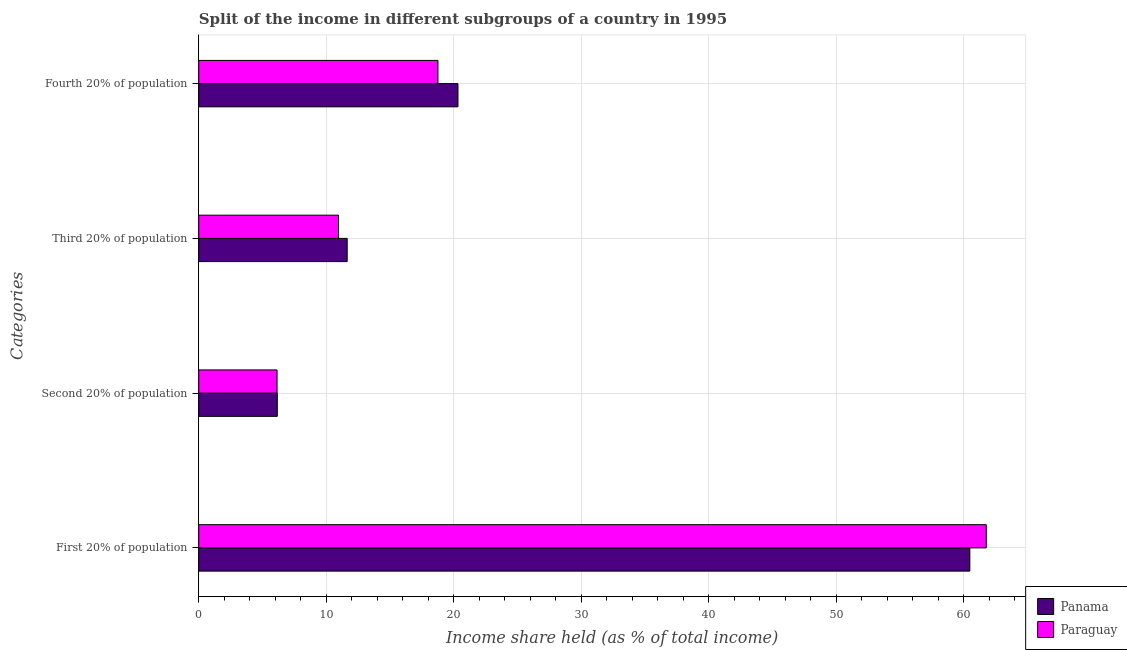How many different coloured bars are there?
Provide a succinct answer. 2. Are the number of bars on each tick of the Y-axis equal?
Your answer should be very brief. Yes. How many bars are there on the 4th tick from the top?
Your answer should be compact. 2. What is the label of the 4th group of bars from the top?
Your answer should be compact. First 20% of population. What is the share of the income held by fourth 20% of the population in Panama?
Provide a succinct answer. 20.33. Across all countries, what is the maximum share of the income held by fourth 20% of the population?
Ensure brevity in your answer.  20.33. Across all countries, what is the minimum share of the income held by first 20% of the population?
Make the answer very short. 60.48. In which country was the share of the income held by second 20% of the population maximum?
Provide a succinct answer. Panama. In which country was the share of the income held by second 20% of the population minimum?
Give a very brief answer. Paraguay. What is the total share of the income held by fourth 20% of the population in the graph?
Make the answer very short. 39.09. What is the difference between the share of the income held by third 20% of the population in Panama and that in Paraguay?
Give a very brief answer. 0.68. What is the difference between the share of the income held by third 20% of the population in Paraguay and the share of the income held by second 20% of the population in Panama?
Offer a very short reply. 4.8. What is the average share of the income held by fourth 20% of the population per country?
Give a very brief answer. 19.55. What is the difference between the share of the income held by second 20% of the population and share of the income held by third 20% of the population in Paraguay?
Keep it short and to the point. -4.82. What is the ratio of the share of the income held by third 20% of the population in Paraguay to that in Panama?
Provide a succinct answer. 0.94. What is the difference between the highest and the second highest share of the income held by first 20% of the population?
Keep it short and to the point. 1.29. What is the difference between the highest and the lowest share of the income held by first 20% of the population?
Your answer should be compact. 1.29. In how many countries, is the share of the income held by third 20% of the population greater than the average share of the income held by third 20% of the population taken over all countries?
Keep it short and to the point. 1. Is the sum of the share of the income held by fourth 20% of the population in Paraguay and Panama greater than the maximum share of the income held by second 20% of the population across all countries?
Provide a short and direct response. Yes. Is it the case that in every country, the sum of the share of the income held by second 20% of the population and share of the income held by first 20% of the population is greater than the sum of share of the income held by fourth 20% of the population and share of the income held by third 20% of the population?
Your response must be concise. Yes. What does the 1st bar from the top in First 20% of population represents?
Provide a succinct answer. Paraguay. What does the 1st bar from the bottom in First 20% of population represents?
Offer a very short reply. Panama. Are all the bars in the graph horizontal?
Your response must be concise. Yes. Are the values on the major ticks of X-axis written in scientific E-notation?
Provide a short and direct response. No. Does the graph contain any zero values?
Your answer should be compact. No. Where does the legend appear in the graph?
Your response must be concise. Bottom right. How many legend labels are there?
Offer a terse response. 2. How are the legend labels stacked?
Provide a succinct answer. Vertical. What is the title of the graph?
Your answer should be very brief. Split of the income in different subgroups of a country in 1995. Does "Nepal" appear as one of the legend labels in the graph?
Provide a short and direct response. No. What is the label or title of the X-axis?
Give a very brief answer. Income share held (as % of total income). What is the label or title of the Y-axis?
Ensure brevity in your answer.  Categories. What is the Income share held (as % of total income) of Panama in First 20% of population?
Provide a succinct answer. 60.48. What is the Income share held (as % of total income) in Paraguay in First 20% of population?
Your answer should be very brief. 61.77. What is the Income share held (as % of total income) of Panama in Second 20% of population?
Ensure brevity in your answer.  6.16. What is the Income share held (as % of total income) of Paraguay in Second 20% of population?
Offer a terse response. 6.14. What is the Income share held (as % of total income) of Panama in Third 20% of population?
Make the answer very short. 11.64. What is the Income share held (as % of total income) of Paraguay in Third 20% of population?
Your response must be concise. 10.96. What is the Income share held (as % of total income) of Panama in Fourth 20% of population?
Offer a terse response. 20.33. What is the Income share held (as % of total income) of Paraguay in Fourth 20% of population?
Keep it short and to the point. 18.76. Across all Categories, what is the maximum Income share held (as % of total income) in Panama?
Your answer should be very brief. 60.48. Across all Categories, what is the maximum Income share held (as % of total income) in Paraguay?
Make the answer very short. 61.77. Across all Categories, what is the minimum Income share held (as % of total income) of Panama?
Provide a succinct answer. 6.16. Across all Categories, what is the minimum Income share held (as % of total income) of Paraguay?
Ensure brevity in your answer.  6.14. What is the total Income share held (as % of total income) in Panama in the graph?
Provide a succinct answer. 98.61. What is the total Income share held (as % of total income) of Paraguay in the graph?
Offer a very short reply. 97.63. What is the difference between the Income share held (as % of total income) of Panama in First 20% of population and that in Second 20% of population?
Your answer should be very brief. 54.32. What is the difference between the Income share held (as % of total income) in Paraguay in First 20% of population and that in Second 20% of population?
Provide a succinct answer. 55.63. What is the difference between the Income share held (as % of total income) in Panama in First 20% of population and that in Third 20% of population?
Make the answer very short. 48.84. What is the difference between the Income share held (as % of total income) in Paraguay in First 20% of population and that in Third 20% of population?
Offer a very short reply. 50.81. What is the difference between the Income share held (as % of total income) of Panama in First 20% of population and that in Fourth 20% of population?
Offer a very short reply. 40.15. What is the difference between the Income share held (as % of total income) of Paraguay in First 20% of population and that in Fourth 20% of population?
Provide a short and direct response. 43.01. What is the difference between the Income share held (as % of total income) of Panama in Second 20% of population and that in Third 20% of population?
Offer a terse response. -5.48. What is the difference between the Income share held (as % of total income) in Paraguay in Second 20% of population and that in Third 20% of population?
Provide a succinct answer. -4.82. What is the difference between the Income share held (as % of total income) in Panama in Second 20% of population and that in Fourth 20% of population?
Offer a very short reply. -14.17. What is the difference between the Income share held (as % of total income) in Paraguay in Second 20% of population and that in Fourth 20% of population?
Keep it short and to the point. -12.62. What is the difference between the Income share held (as % of total income) in Panama in Third 20% of population and that in Fourth 20% of population?
Make the answer very short. -8.69. What is the difference between the Income share held (as % of total income) in Paraguay in Third 20% of population and that in Fourth 20% of population?
Offer a very short reply. -7.8. What is the difference between the Income share held (as % of total income) of Panama in First 20% of population and the Income share held (as % of total income) of Paraguay in Second 20% of population?
Make the answer very short. 54.34. What is the difference between the Income share held (as % of total income) of Panama in First 20% of population and the Income share held (as % of total income) of Paraguay in Third 20% of population?
Keep it short and to the point. 49.52. What is the difference between the Income share held (as % of total income) of Panama in First 20% of population and the Income share held (as % of total income) of Paraguay in Fourth 20% of population?
Provide a short and direct response. 41.72. What is the difference between the Income share held (as % of total income) in Panama in Third 20% of population and the Income share held (as % of total income) in Paraguay in Fourth 20% of population?
Your answer should be compact. -7.12. What is the average Income share held (as % of total income) in Panama per Categories?
Provide a short and direct response. 24.65. What is the average Income share held (as % of total income) in Paraguay per Categories?
Your response must be concise. 24.41. What is the difference between the Income share held (as % of total income) of Panama and Income share held (as % of total income) of Paraguay in First 20% of population?
Your response must be concise. -1.29. What is the difference between the Income share held (as % of total income) in Panama and Income share held (as % of total income) in Paraguay in Second 20% of population?
Ensure brevity in your answer.  0.02. What is the difference between the Income share held (as % of total income) in Panama and Income share held (as % of total income) in Paraguay in Third 20% of population?
Offer a very short reply. 0.68. What is the difference between the Income share held (as % of total income) of Panama and Income share held (as % of total income) of Paraguay in Fourth 20% of population?
Keep it short and to the point. 1.57. What is the ratio of the Income share held (as % of total income) in Panama in First 20% of population to that in Second 20% of population?
Give a very brief answer. 9.82. What is the ratio of the Income share held (as % of total income) of Paraguay in First 20% of population to that in Second 20% of population?
Give a very brief answer. 10.06. What is the ratio of the Income share held (as % of total income) in Panama in First 20% of population to that in Third 20% of population?
Keep it short and to the point. 5.2. What is the ratio of the Income share held (as % of total income) in Paraguay in First 20% of population to that in Third 20% of population?
Your answer should be compact. 5.64. What is the ratio of the Income share held (as % of total income) of Panama in First 20% of population to that in Fourth 20% of population?
Your response must be concise. 2.97. What is the ratio of the Income share held (as % of total income) in Paraguay in First 20% of population to that in Fourth 20% of population?
Ensure brevity in your answer.  3.29. What is the ratio of the Income share held (as % of total income) of Panama in Second 20% of population to that in Third 20% of population?
Ensure brevity in your answer.  0.53. What is the ratio of the Income share held (as % of total income) in Paraguay in Second 20% of population to that in Third 20% of population?
Provide a succinct answer. 0.56. What is the ratio of the Income share held (as % of total income) of Panama in Second 20% of population to that in Fourth 20% of population?
Offer a terse response. 0.3. What is the ratio of the Income share held (as % of total income) in Paraguay in Second 20% of population to that in Fourth 20% of population?
Provide a short and direct response. 0.33. What is the ratio of the Income share held (as % of total income) in Panama in Third 20% of population to that in Fourth 20% of population?
Provide a succinct answer. 0.57. What is the ratio of the Income share held (as % of total income) of Paraguay in Third 20% of population to that in Fourth 20% of population?
Your answer should be compact. 0.58. What is the difference between the highest and the second highest Income share held (as % of total income) in Panama?
Ensure brevity in your answer.  40.15. What is the difference between the highest and the second highest Income share held (as % of total income) in Paraguay?
Keep it short and to the point. 43.01. What is the difference between the highest and the lowest Income share held (as % of total income) of Panama?
Your answer should be very brief. 54.32. What is the difference between the highest and the lowest Income share held (as % of total income) in Paraguay?
Offer a terse response. 55.63. 